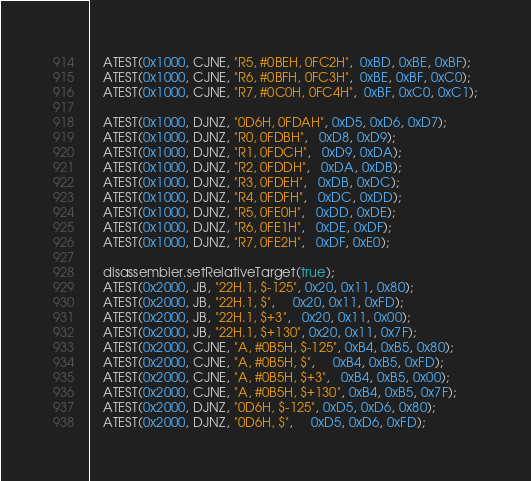<code> <loc_0><loc_0><loc_500><loc_500><_C++_>    ATEST(0x1000, CJNE, "R5, #0BEH, 0FC2H",  0xBD, 0xBE, 0xBF);
    ATEST(0x1000, CJNE, "R6, #0BFH, 0FC3H",  0xBE, 0xBF, 0xC0);
    ATEST(0x1000, CJNE, "R7, #0C0H, 0FC4H",  0xBF, 0xC0, 0xC1);

    ATEST(0x1000, DJNZ, "0D6H, 0FDAH", 0xD5, 0xD6, 0xD7);
    ATEST(0x1000, DJNZ, "R0, 0FDBH",   0xD8, 0xD9);
    ATEST(0x1000, DJNZ, "R1, 0FDCH",   0xD9, 0xDA);
    ATEST(0x1000, DJNZ, "R2, 0FDDH",   0xDA, 0xDB);
    ATEST(0x1000, DJNZ, "R3, 0FDEH",   0xDB, 0xDC);
    ATEST(0x1000, DJNZ, "R4, 0FDFH",   0xDC, 0xDD);
    ATEST(0x1000, DJNZ, "R5, 0FE0H",   0xDD, 0xDE);
    ATEST(0x1000, DJNZ, "R6, 0FE1H",   0xDE, 0xDF);
    ATEST(0x1000, DJNZ, "R7, 0FE2H",   0xDF, 0xE0);

    disassembler.setRelativeTarget(true);
    ATEST(0x2000, JB, "22H.1, $-125", 0x20, 0x11, 0x80);
    ATEST(0x2000, JB, "22H.1, $",     0x20, 0x11, 0xFD);
    ATEST(0x2000, JB, "22H.1, $+3",   0x20, 0x11, 0x00);
    ATEST(0x2000, JB, "22H.1, $+130", 0x20, 0x11, 0x7F);
    ATEST(0x2000, CJNE, "A, #0B5H, $-125", 0xB4, 0xB5, 0x80);
    ATEST(0x2000, CJNE, "A, #0B5H, $",     0xB4, 0xB5, 0xFD);
    ATEST(0x2000, CJNE, "A, #0B5H, $+3",   0xB4, 0xB5, 0x00);
    ATEST(0x2000, CJNE, "A, #0B5H, $+130", 0xB4, 0xB5, 0x7F);
    ATEST(0x2000, DJNZ, "0D6H, $-125", 0xD5, 0xD6, 0x80);
    ATEST(0x2000, DJNZ, "0D6H, $",     0xD5, 0xD6, 0xFD);</code> 